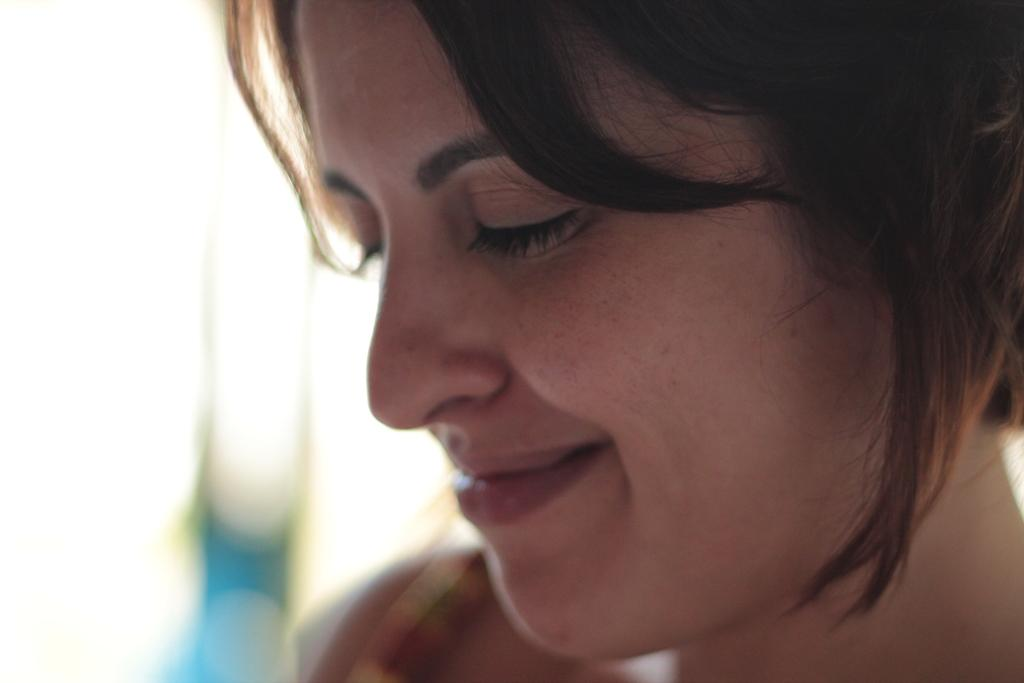Who is present in the image? There is a woman in the image. What is the woman doing in the image? The woman is smiling. What type of comb does the woman use to manage her hair in the image? There is no comb or reference to hair management in the image; the woman is simply smiling. 